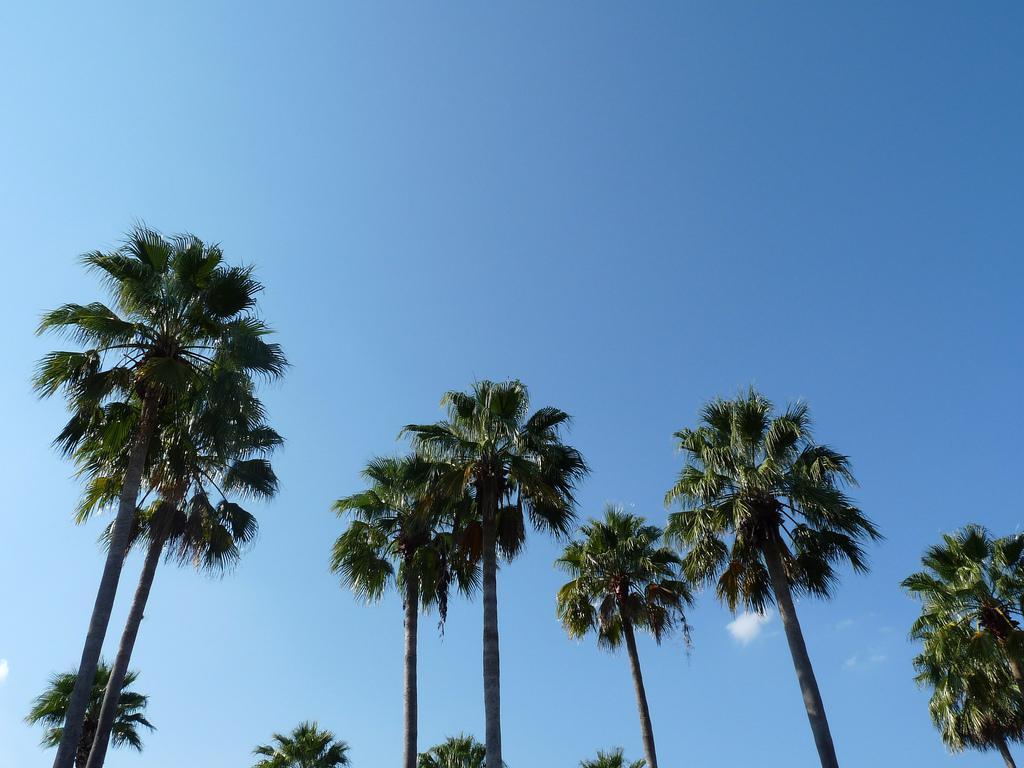Describe this image in one or two sentences. In this picture I can see there are trees and the sky is clear. 